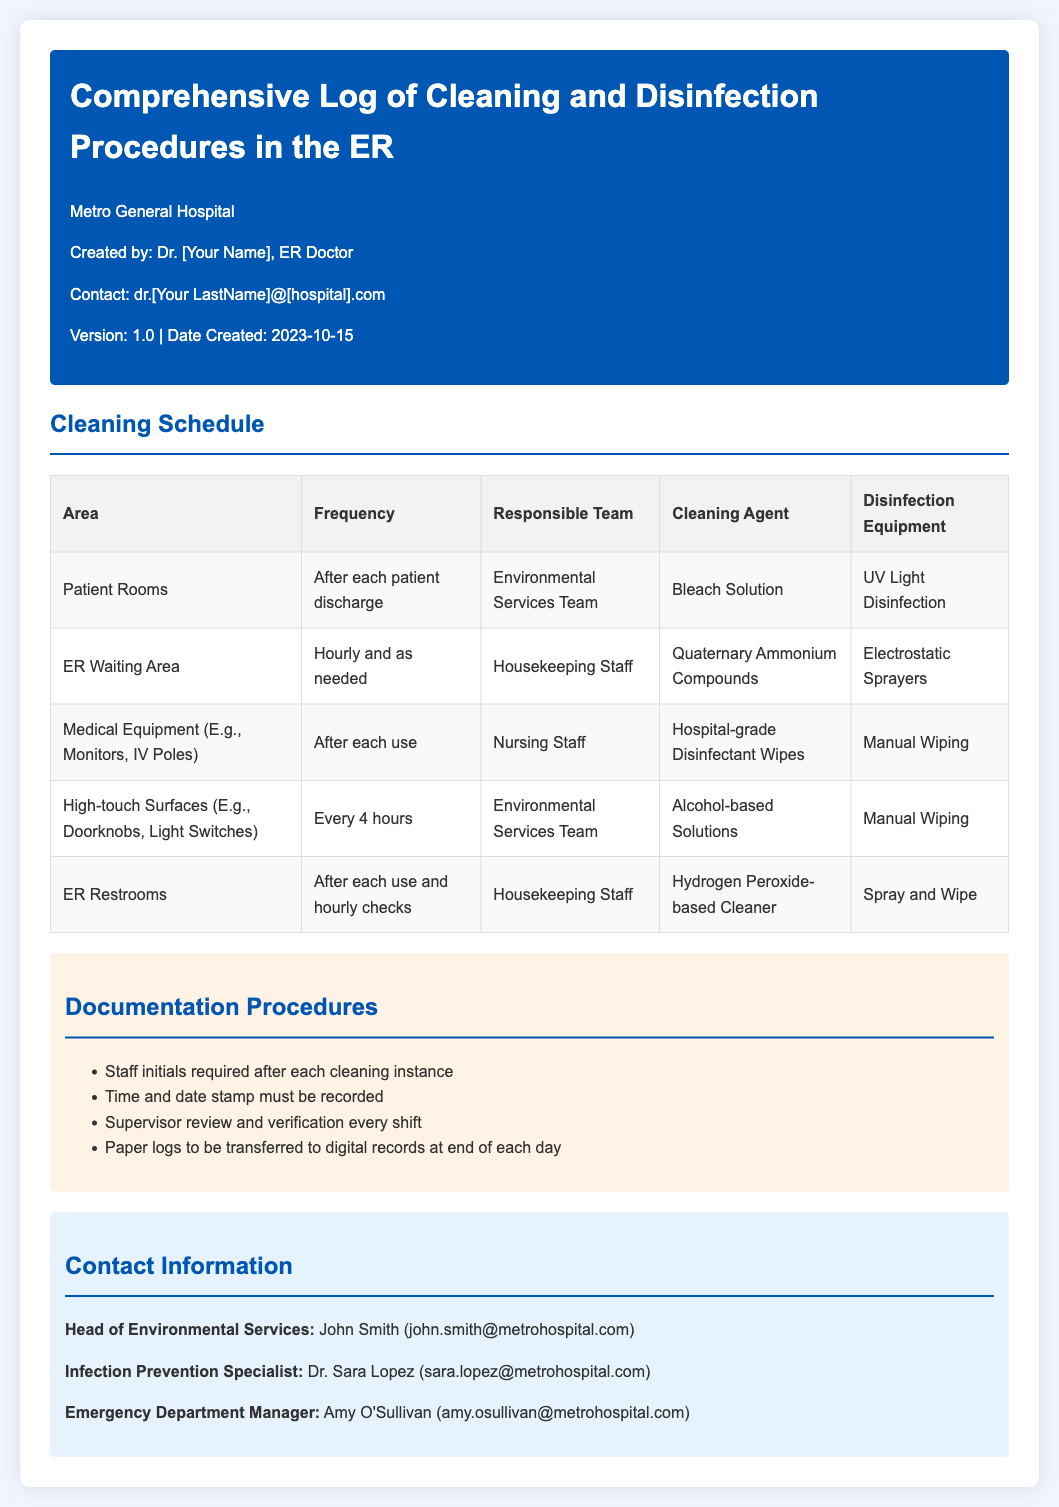What is the title of the document? The title is found in the header of the document.
Answer: Comprehensive Log of Cleaning and Disinfection Procedures in the ER Who is responsible for cleaning the ER waiting area? The responsible team is indicated in the cleaning schedule table.
Answer: Housekeeping Staff How often are patient rooms cleaned? This information is available in the cleaning schedule under the frequency column.
Answer: After each patient discharge What type of cleaning agent is used for high-touch surfaces? This detail can be found in the cleaning schedule table under cleaning agent.
Answer: Alcohol-based Solutions What must be recorded after each cleaning instance? This is specified in the documentation procedures section of the document.
Answer: Staff initials Who is the Emergency Department Manager? The contact information section lists the Emergency Department Manager.
Answer: Amy O'Sullivan What is the time frame for the supervisor's review? This can be inferred from the documentation procedures outlined in the document.
Answer: Every shift What disinfectant equipment is used for patient rooms? The cleaning schedule table indicates which equipment is used.
Answer: UV Light Disinfection How frequently are ER restrooms checked? The frequency for restroom checks is stated in the cleaning schedule.
Answer: After each use and hourly checks 